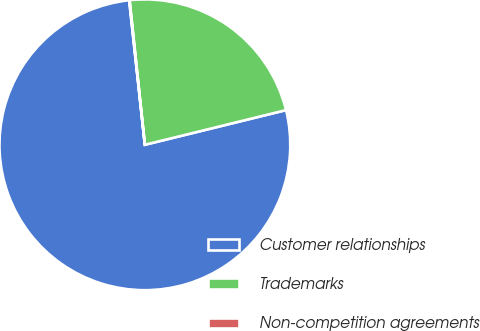<chart> <loc_0><loc_0><loc_500><loc_500><pie_chart><fcel>Customer relationships<fcel>Trademarks<fcel>Non-competition agreements<nl><fcel>77.11%<fcel>22.84%<fcel>0.05%<nl></chart> 